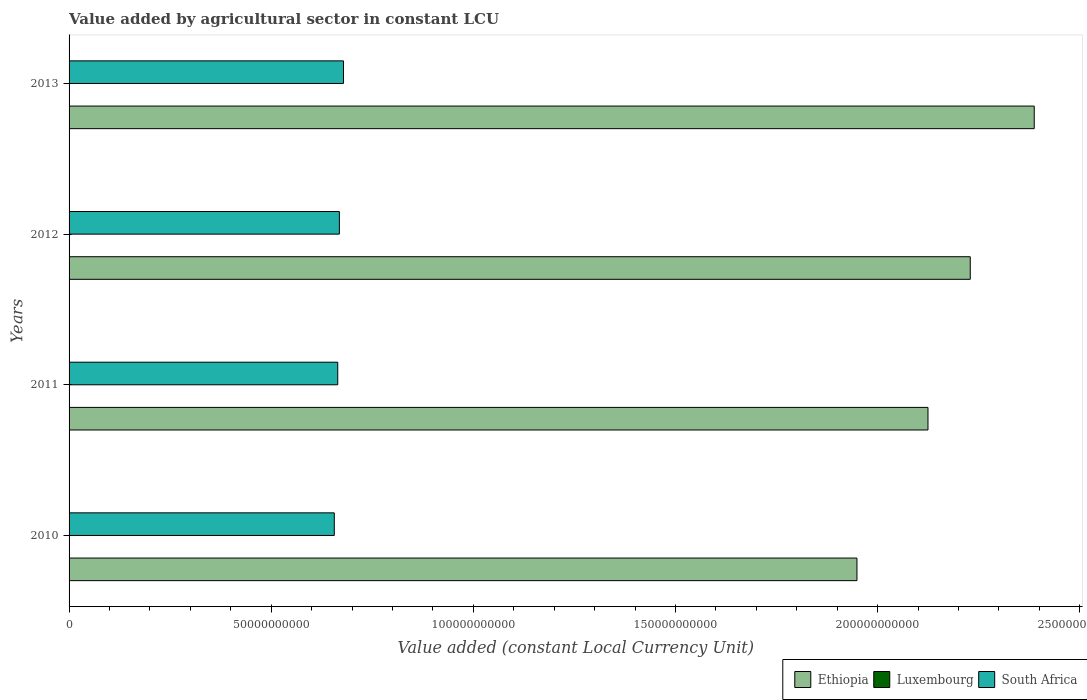How many different coloured bars are there?
Provide a short and direct response. 3. How many groups of bars are there?
Provide a succinct answer. 4. Are the number of bars per tick equal to the number of legend labels?
Make the answer very short. Yes. How many bars are there on the 1st tick from the top?
Provide a short and direct response. 3. In how many cases, is the number of bars for a given year not equal to the number of legend labels?
Ensure brevity in your answer.  0. What is the value added by agricultural sector in Ethiopia in 2013?
Give a very brief answer. 2.39e+11. Across all years, what is the maximum value added by agricultural sector in Ethiopia?
Offer a very short reply. 2.39e+11. Across all years, what is the minimum value added by agricultural sector in Ethiopia?
Your answer should be very brief. 1.95e+11. In which year was the value added by agricultural sector in Luxembourg maximum?
Provide a succinct answer. 2012. In which year was the value added by agricultural sector in Luxembourg minimum?
Ensure brevity in your answer.  2013. What is the total value added by agricultural sector in South Africa in the graph?
Your answer should be very brief. 2.67e+11. What is the difference between the value added by agricultural sector in Ethiopia in 2010 and that in 2011?
Your response must be concise. -1.76e+1. What is the difference between the value added by agricultural sector in South Africa in 2010 and the value added by agricultural sector in Ethiopia in 2012?
Your answer should be compact. -1.57e+11. What is the average value added by agricultural sector in Luxembourg per year?
Provide a short and direct response. 9.09e+07. In the year 2013, what is the difference between the value added by agricultural sector in Ethiopia and value added by agricultural sector in South Africa?
Your response must be concise. 1.71e+11. What is the ratio of the value added by agricultural sector in Ethiopia in 2010 to that in 2011?
Your answer should be compact. 0.92. Is the difference between the value added by agricultural sector in Ethiopia in 2010 and 2013 greater than the difference between the value added by agricultural sector in South Africa in 2010 and 2013?
Provide a succinct answer. No. What is the difference between the highest and the second highest value added by agricultural sector in Luxembourg?
Your answer should be compact. 8.90e+06. What is the difference between the highest and the lowest value added by agricultural sector in Ethiopia?
Provide a short and direct response. 4.39e+1. In how many years, is the value added by agricultural sector in South Africa greater than the average value added by agricultural sector in South Africa taken over all years?
Your response must be concise. 2. Is the sum of the value added by agricultural sector in South Africa in 2011 and 2012 greater than the maximum value added by agricultural sector in Luxembourg across all years?
Provide a succinct answer. Yes. What does the 2nd bar from the top in 2011 represents?
Your answer should be very brief. Luxembourg. What does the 3rd bar from the bottom in 2012 represents?
Offer a very short reply. South Africa. Is it the case that in every year, the sum of the value added by agricultural sector in Luxembourg and value added by agricultural sector in South Africa is greater than the value added by agricultural sector in Ethiopia?
Your answer should be compact. No. How many bars are there?
Make the answer very short. 12. How many years are there in the graph?
Your answer should be compact. 4. Does the graph contain grids?
Ensure brevity in your answer.  No. How are the legend labels stacked?
Offer a very short reply. Horizontal. What is the title of the graph?
Your answer should be compact. Value added by agricultural sector in constant LCU. What is the label or title of the X-axis?
Provide a succinct answer. Value added (constant Local Currency Unit). What is the Value added (constant Local Currency Unit) in Ethiopia in 2010?
Make the answer very short. 1.95e+11. What is the Value added (constant Local Currency Unit) of Luxembourg in 2010?
Offer a very short reply. 1.00e+08. What is the Value added (constant Local Currency Unit) of South Africa in 2010?
Your response must be concise. 6.56e+1. What is the Value added (constant Local Currency Unit) of Ethiopia in 2011?
Provide a succinct answer. 2.12e+11. What is the Value added (constant Local Currency Unit) in Luxembourg in 2011?
Provide a short and direct response. 8.42e+07. What is the Value added (constant Local Currency Unit) of South Africa in 2011?
Your answer should be very brief. 6.65e+1. What is the Value added (constant Local Currency Unit) in Ethiopia in 2012?
Offer a terse response. 2.23e+11. What is the Value added (constant Local Currency Unit) in Luxembourg in 2012?
Ensure brevity in your answer.  1.09e+08. What is the Value added (constant Local Currency Unit) of South Africa in 2012?
Ensure brevity in your answer.  6.69e+1. What is the Value added (constant Local Currency Unit) in Ethiopia in 2013?
Your answer should be compact. 2.39e+11. What is the Value added (constant Local Currency Unit) in Luxembourg in 2013?
Keep it short and to the point. 7.05e+07. What is the Value added (constant Local Currency Unit) in South Africa in 2013?
Make the answer very short. 6.79e+1. Across all years, what is the maximum Value added (constant Local Currency Unit) of Ethiopia?
Keep it short and to the point. 2.39e+11. Across all years, what is the maximum Value added (constant Local Currency Unit) in Luxembourg?
Provide a short and direct response. 1.09e+08. Across all years, what is the maximum Value added (constant Local Currency Unit) in South Africa?
Give a very brief answer. 6.79e+1. Across all years, what is the minimum Value added (constant Local Currency Unit) in Ethiopia?
Your response must be concise. 1.95e+11. Across all years, what is the minimum Value added (constant Local Currency Unit) in Luxembourg?
Offer a terse response. 7.05e+07. Across all years, what is the minimum Value added (constant Local Currency Unit) in South Africa?
Your answer should be very brief. 6.56e+1. What is the total Value added (constant Local Currency Unit) of Ethiopia in the graph?
Your answer should be compact. 8.69e+11. What is the total Value added (constant Local Currency Unit) of Luxembourg in the graph?
Your answer should be compact. 3.64e+08. What is the total Value added (constant Local Currency Unit) in South Africa in the graph?
Your answer should be compact. 2.67e+11. What is the difference between the Value added (constant Local Currency Unit) in Ethiopia in 2010 and that in 2011?
Ensure brevity in your answer.  -1.76e+1. What is the difference between the Value added (constant Local Currency Unit) in Luxembourg in 2010 and that in 2011?
Your answer should be compact. 1.58e+07. What is the difference between the Value added (constant Local Currency Unit) in South Africa in 2010 and that in 2011?
Your answer should be compact. -8.59e+08. What is the difference between the Value added (constant Local Currency Unit) in Ethiopia in 2010 and that in 2012?
Your response must be concise. -2.80e+1. What is the difference between the Value added (constant Local Currency Unit) in Luxembourg in 2010 and that in 2012?
Make the answer very short. -8.90e+06. What is the difference between the Value added (constant Local Currency Unit) of South Africa in 2010 and that in 2012?
Make the answer very short. -1.26e+09. What is the difference between the Value added (constant Local Currency Unit) in Ethiopia in 2010 and that in 2013?
Provide a succinct answer. -4.39e+1. What is the difference between the Value added (constant Local Currency Unit) in Luxembourg in 2010 and that in 2013?
Your answer should be very brief. 2.95e+07. What is the difference between the Value added (constant Local Currency Unit) of South Africa in 2010 and that in 2013?
Provide a short and direct response. -2.28e+09. What is the difference between the Value added (constant Local Currency Unit) of Ethiopia in 2011 and that in 2012?
Ensure brevity in your answer.  -1.05e+1. What is the difference between the Value added (constant Local Currency Unit) of Luxembourg in 2011 and that in 2012?
Keep it short and to the point. -2.47e+07. What is the difference between the Value added (constant Local Currency Unit) in South Africa in 2011 and that in 2012?
Ensure brevity in your answer.  -3.97e+08. What is the difference between the Value added (constant Local Currency Unit) in Ethiopia in 2011 and that in 2013?
Your answer should be compact. -2.63e+1. What is the difference between the Value added (constant Local Currency Unit) of Luxembourg in 2011 and that in 2013?
Provide a short and direct response. 1.37e+07. What is the difference between the Value added (constant Local Currency Unit) of South Africa in 2011 and that in 2013?
Provide a succinct answer. -1.42e+09. What is the difference between the Value added (constant Local Currency Unit) of Ethiopia in 2012 and that in 2013?
Offer a very short reply. -1.58e+1. What is the difference between the Value added (constant Local Currency Unit) of Luxembourg in 2012 and that in 2013?
Make the answer very short. 3.84e+07. What is the difference between the Value added (constant Local Currency Unit) of South Africa in 2012 and that in 2013?
Your answer should be compact. -1.02e+09. What is the difference between the Value added (constant Local Currency Unit) of Ethiopia in 2010 and the Value added (constant Local Currency Unit) of Luxembourg in 2011?
Your answer should be compact. 1.95e+11. What is the difference between the Value added (constant Local Currency Unit) of Ethiopia in 2010 and the Value added (constant Local Currency Unit) of South Africa in 2011?
Ensure brevity in your answer.  1.28e+11. What is the difference between the Value added (constant Local Currency Unit) of Luxembourg in 2010 and the Value added (constant Local Currency Unit) of South Africa in 2011?
Provide a short and direct response. -6.64e+1. What is the difference between the Value added (constant Local Currency Unit) of Ethiopia in 2010 and the Value added (constant Local Currency Unit) of Luxembourg in 2012?
Ensure brevity in your answer.  1.95e+11. What is the difference between the Value added (constant Local Currency Unit) in Ethiopia in 2010 and the Value added (constant Local Currency Unit) in South Africa in 2012?
Your response must be concise. 1.28e+11. What is the difference between the Value added (constant Local Currency Unit) of Luxembourg in 2010 and the Value added (constant Local Currency Unit) of South Africa in 2012?
Offer a very short reply. -6.68e+1. What is the difference between the Value added (constant Local Currency Unit) in Ethiopia in 2010 and the Value added (constant Local Currency Unit) in Luxembourg in 2013?
Offer a terse response. 1.95e+11. What is the difference between the Value added (constant Local Currency Unit) of Ethiopia in 2010 and the Value added (constant Local Currency Unit) of South Africa in 2013?
Offer a terse response. 1.27e+11. What is the difference between the Value added (constant Local Currency Unit) in Luxembourg in 2010 and the Value added (constant Local Currency Unit) in South Africa in 2013?
Provide a short and direct response. -6.78e+1. What is the difference between the Value added (constant Local Currency Unit) in Ethiopia in 2011 and the Value added (constant Local Currency Unit) in Luxembourg in 2012?
Offer a terse response. 2.12e+11. What is the difference between the Value added (constant Local Currency Unit) in Ethiopia in 2011 and the Value added (constant Local Currency Unit) in South Africa in 2012?
Keep it short and to the point. 1.46e+11. What is the difference between the Value added (constant Local Currency Unit) of Luxembourg in 2011 and the Value added (constant Local Currency Unit) of South Africa in 2012?
Your answer should be very brief. -6.68e+1. What is the difference between the Value added (constant Local Currency Unit) of Ethiopia in 2011 and the Value added (constant Local Currency Unit) of Luxembourg in 2013?
Your response must be concise. 2.12e+11. What is the difference between the Value added (constant Local Currency Unit) of Ethiopia in 2011 and the Value added (constant Local Currency Unit) of South Africa in 2013?
Make the answer very short. 1.45e+11. What is the difference between the Value added (constant Local Currency Unit) of Luxembourg in 2011 and the Value added (constant Local Currency Unit) of South Africa in 2013?
Offer a very short reply. -6.78e+1. What is the difference between the Value added (constant Local Currency Unit) in Ethiopia in 2012 and the Value added (constant Local Currency Unit) in Luxembourg in 2013?
Ensure brevity in your answer.  2.23e+11. What is the difference between the Value added (constant Local Currency Unit) in Ethiopia in 2012 and the Value added (constant Local Currency Unit) in South Africa in 2013?
Provide a succinct answer. 1.55e+11. What is the difference between the Value added (constant Local Currency Unit) of Luxembourg in 2012 and the Value added (constant Local Currency Unit) of South Africa in 2013?
Provide a succinct answer. -6.78e+1. What is the average Value added (constant Local Currency Unit) in Ethiopia per year?
Provide a short and direct response. 2.17e+11. What is the average Value added (constant Local Currency Unit) of Luxembourg per year?
Ensure brevity in your answer.  9.09e+07. What is the average Value added (constant Local Currency Unit) in South Africa per year?
Give a very brief answer. 6.67e+1. In the year 2010, what is the difference between the Value added (constant Local Currency Unit) in Ethiopia and Value added (constant Local Currency Unit) in Luxembourg?
Your response must be concise. 1.95e+11. In the year 2010, what is the difference between the Value added (constant Local Currency Unit) in Ethiopia and Value added (constant Local Currency Unit) in South Africa?
Offer a very short reply. 1.29e+11. In the year 2010, what is the difference between the Value added (constant Local Currency Unit) of Luxembourg and Value added (constant Local Currency Unit) of South Africa?
Offer a terse response. -6.55e+1. In the year 2011, what is the difference between the Value added (constant Local Currency Unit) in Ethiopia and Value added (constant Local Currency Unit) in Luxembourg?
Make the answer very short. 2.12e+11. In the year 2011, what is the difference between the Value added (constant Local Currency Unit) of Ethiopia and Value added (constant Local Currency Unit) of South Africa?
Give a very brief answer. 1.46e+11. In the year 2011, what is the difference between the Value added (constant Local Currency Unit) in Luxembourg and Value added (constant Local Currency Unit) in South Africa?
Offer a very short reply. -6.64e+1. In the year 2012, what is the difference between the Value added (constant Local Currency Unit) in Ethiopia and Value added (constant Local Currency Unit) in Luxembourg?
Your answer should be very brief. 2.23e+11. In the year 2012, what is the difference between the Value added (constant Local Currency Unit) of Ethiopia and Value added (constant Local Currency Unit) of South Africa?
Ensure brevity in your answer.  1.56e+11. In the year 2012, what is the difference between the Value added (constant Local Currency Unit) of Luxembourg and Value added (constant Local Currency Unit) of South Africa?
Your answer should be very brief. -6.68e+1. In the year 2013, what is the difference between the Value added (constant Local Currency Unit) of Ethiopia and Value added (constant Local Currency Unit) of Luxembourg?
Provide a succinct answer. 2.39e+11. In the year 2013, what is the difference between the Value added (constant Local Currency Unit) of Ethiopia and Value added (constant Local Currency Unit) of South Africa?
Give a very brief answer. 1.71e+11. In the year 2013, what is the difference between the Value added (constant Local Currency Unit) in Luxembourg and Value added (constant Local Currency Unit) in South Africa?
Offer a very short reply. -6.78e+1. What is the ratio of the Value added (constant Local Currency Unit) in Ethiopia in 2010 to that in 2011?
Your answer should be very brief. 0.92. What is the ratio of the Value added (constant Local Currency Unit) of Luxembourg in 2010 to that in 2011?
Give a very brief answer. 1.19. What is the ratio of the Value added (constant Local Currency Unit) of South Africa in 2010 to that in 2011?
Your response must be concise. 0.99. What is the ratio of the Value added (constant Local Currency Unit) in Ethiopia in 2010 to that in 2012?
Your answer should be very brief. 0.87. What is the ratio of the Value added (constant Local Currency Unit) in Luxembourg in 2010 to that in 2012?
Ensure brevity in your answer.  0.92. What is the ratio of the Value added (constant Local Currency Unit) of South Africa in 2010 to that in 2012?
Your response must be concise. 0.98. What is the ratio of the Value added (constant Local Currency Unit) in Ethiopia in 2010 to that in 2013?
Provide a succinct answer. 0.82. What is the ratio of the Value added (constant Local Currency Unit) of Luxembourg in 2010 to that in 2013?
Your answer should be very brief. 1.42. What is the ratio of the Value added (constant Local Currency Unit) in South Africa in 2010 to that in 2013?
Make the answer very short. 0.97. What is the ratio of the Value added (constant Local Currency Unit) of Ethiopia in 2011 to that in 2012?
Your response must be concise. 0.95. What is the ratio of the Value added (constant Local Currency Unit) of Luxembourg in 2011 to that in 2012?
Your answer should be compact. 0.77. What is the ratio of the Value added (constant Local Currency Unit) in Ethiopia in 2011 to that in 2013?
Your answer should be compact. 0.89. What is the ratio of the Value added (constant Local Currency Unit) of Luxembourg in 2011 to that in 2013?
Offer a very short reply. 1.19. What is the ratio of the Value added (constant Local Currency Unit) of South Africa in 2011 to that in 2013?
Provide a short and direct response. 0.98. What is the ratio of the Value added (constant Local Currency Unit) of Ethiopia in 2012 to that in 2013?
Offer a terse response. 0.93. What is the ratio of the Value added (constant Local Currency Unit) of Luxembourg in 2012 to that in 2013?
Provide a succinct answer. 1.54. What is the ratio of the Value added (constant Local Currency Unit) in South Africa in 2012 to that in 2013?
Your answer should be very brief. 0.98. What is the difference between the highest and the second highest Value added (constant Local Currency Unit) of Ethiopia?
Your response must be concise. 1.58e+1. What is the difference between the highest and the second highest Value added (constant Local Currency Unit) of Luxembourg?
Ensure brevity in your answer.  8.90e+06. What is the difference between the highest and the second highest Value added (constant Local Currency Unit) in South Africa?
Provide a short and direct response. 1.02e+09. What is the difference between the highest and the lowest Value added (constant Local Currency Unit) in Ethiopia?
Keep it short and to the point. 4.39e+1. What is the difference between the highest and the lowest Value added (constant Local Currency Unit) of Luxembourg?
Keep it short and to the point. 3.84e+07. What is the difference between the highest and the lowest Value added (constant Local Currency Unit) of South Africa?
Provide a short and direct response. 2.28e+09. 